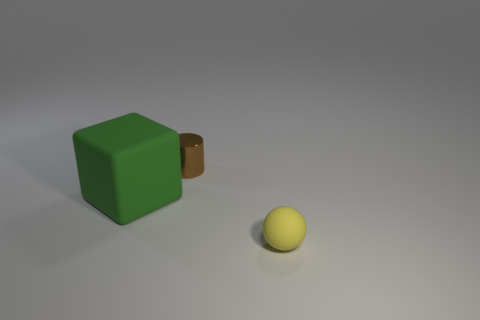Add 2 large purple metal things. How many objects exist? 5 Subtract all balls. How many objects are left? 2 Subtract all green cylinders. Subtract all brown cubes. How many cylinders are left? 1 Subtract all small yellow balls. Subtract all small metal cylinders. How many objects are left? 1 Add 2 large green rubber things. How many large green rubber things are left? 3 Add 3 red metal blocks. How many red metal blocks exist? 3 Subtract 0 green spheres. How many objects are left? 3 